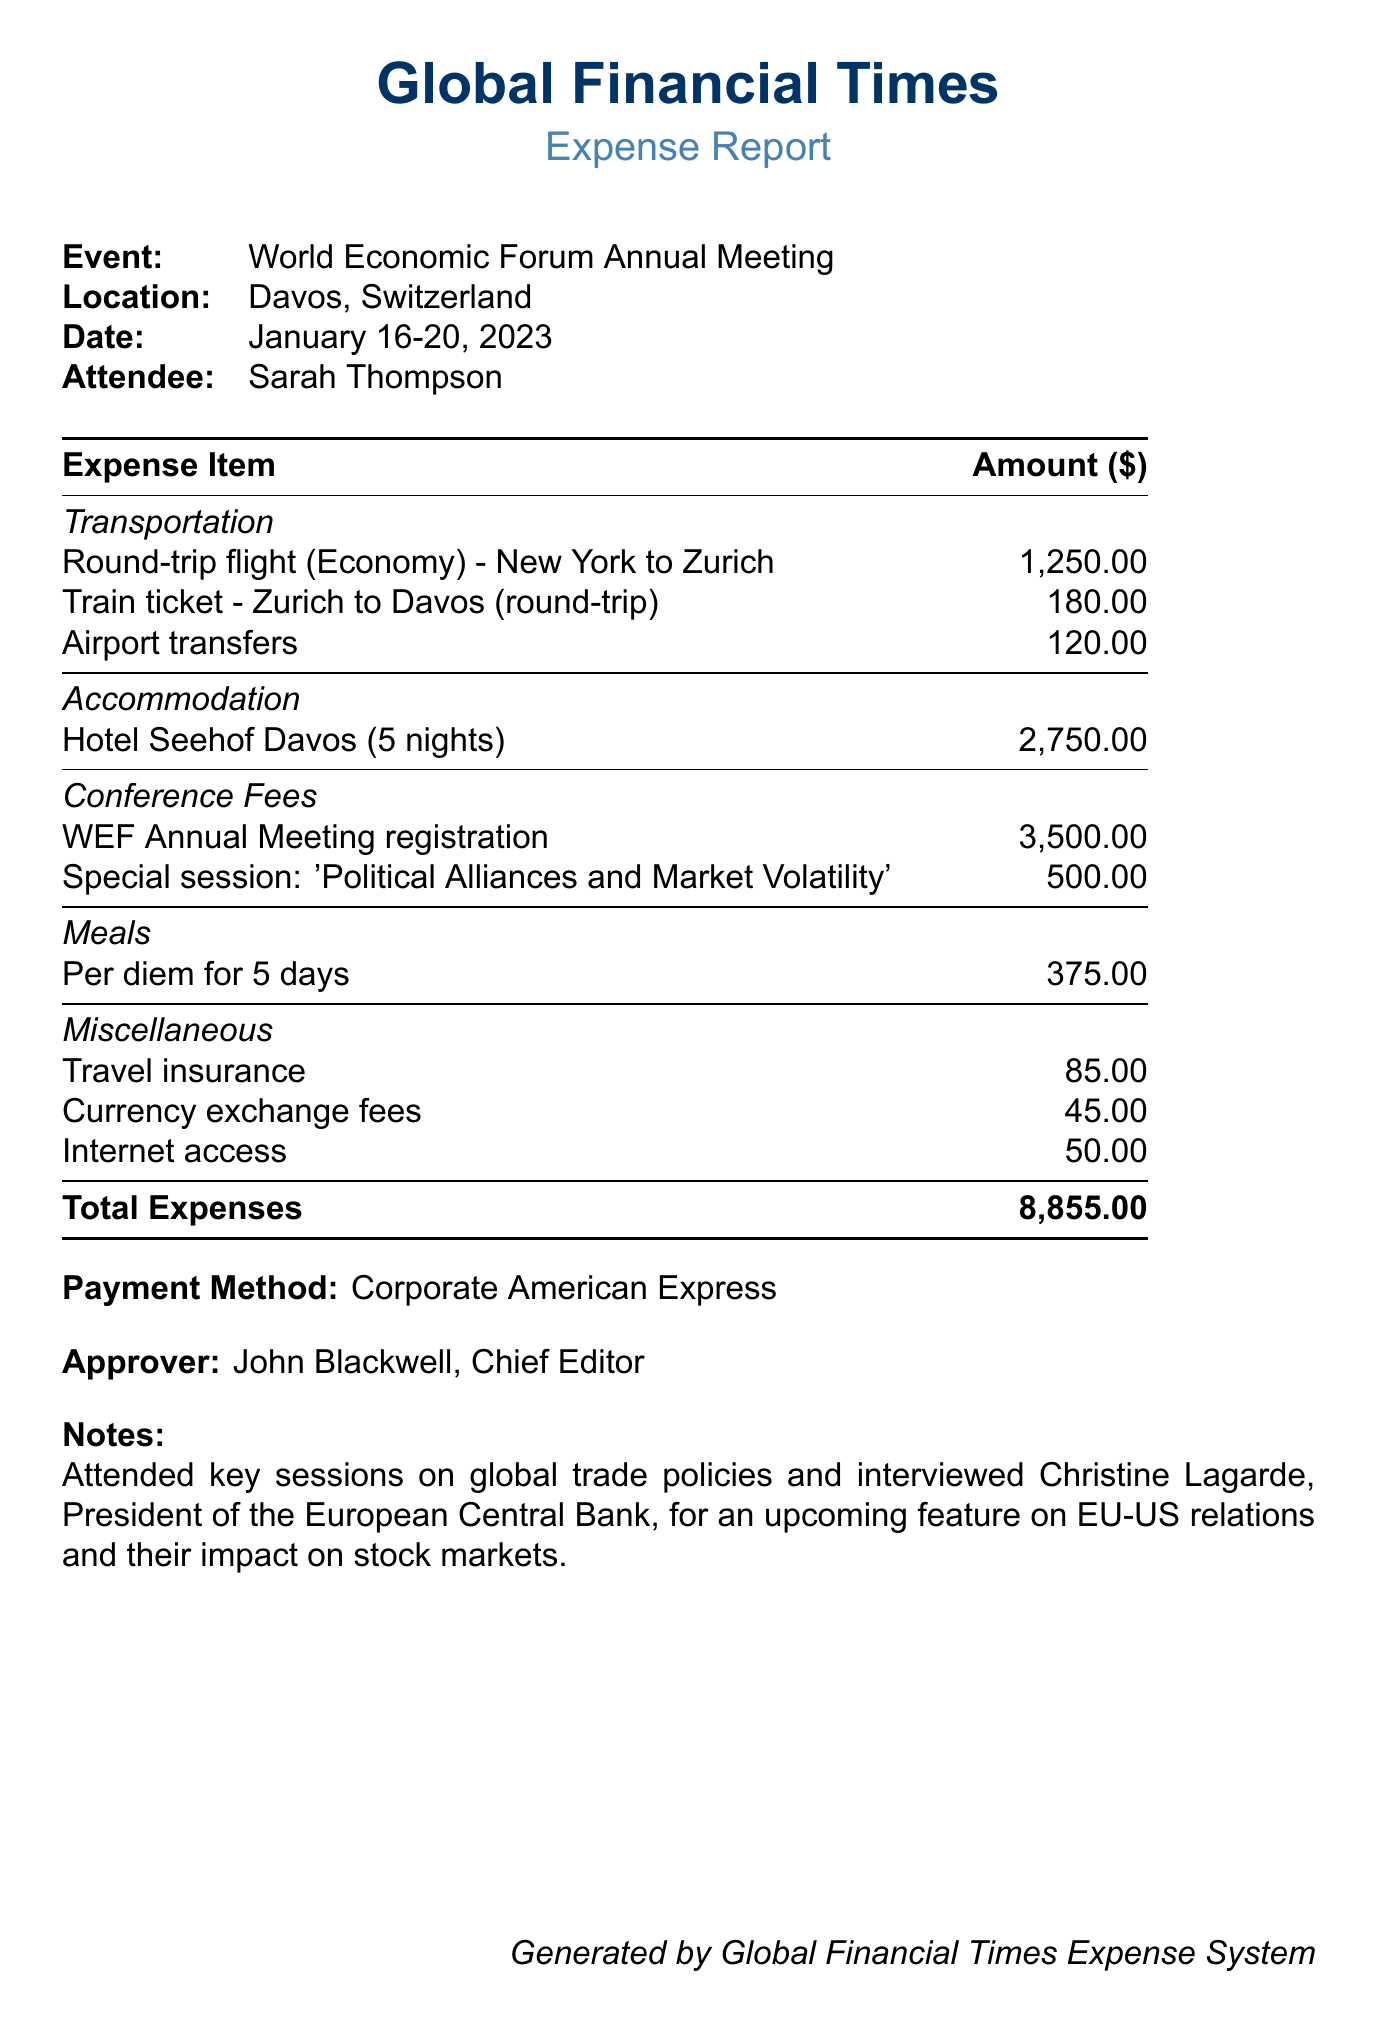What is the location of the event? The location is explicitly stated in the document as Davos, Switzerland.
Answer: Davos, Switzerland Who is the attendee? The name of the attendee is mentioned directly in the document as Sarah Thompson.
Answer: Sarah Thompson What are the total expenses? The total expenses are summarized clearly at the end of the document as 8,855.00.
Answer: 8,855.00 What was the conference fee for the special session? The document lists the amount for the special session related to political alliances as 500.00.
Answer: 500.00 Who approved the expense report? The approver is named in the document as John Blackwell, Chief Editor.
Answer: John Blackwell, Chief Editor How many nights was the accommodation booked for? The document specifies that the accommodation at Hotel Seehof Davos was for 5 nights.
Answer: 5 nights What payment method was used for the expenses? The method of payment is stated clearly in the document as Corporate American Express.
Answer: Corporate American Express What type of insurance was included in the miscellaneous expenses? The document details that travel insurance is one of the miscellaneous expense items listed.
Answer: Travel insurance What key session topic did the attendee cover at the conference? The notes section mentions a key session on political alliances and market volatility attended by the reporter.
Answer: Political Alliances and Market Volatility 